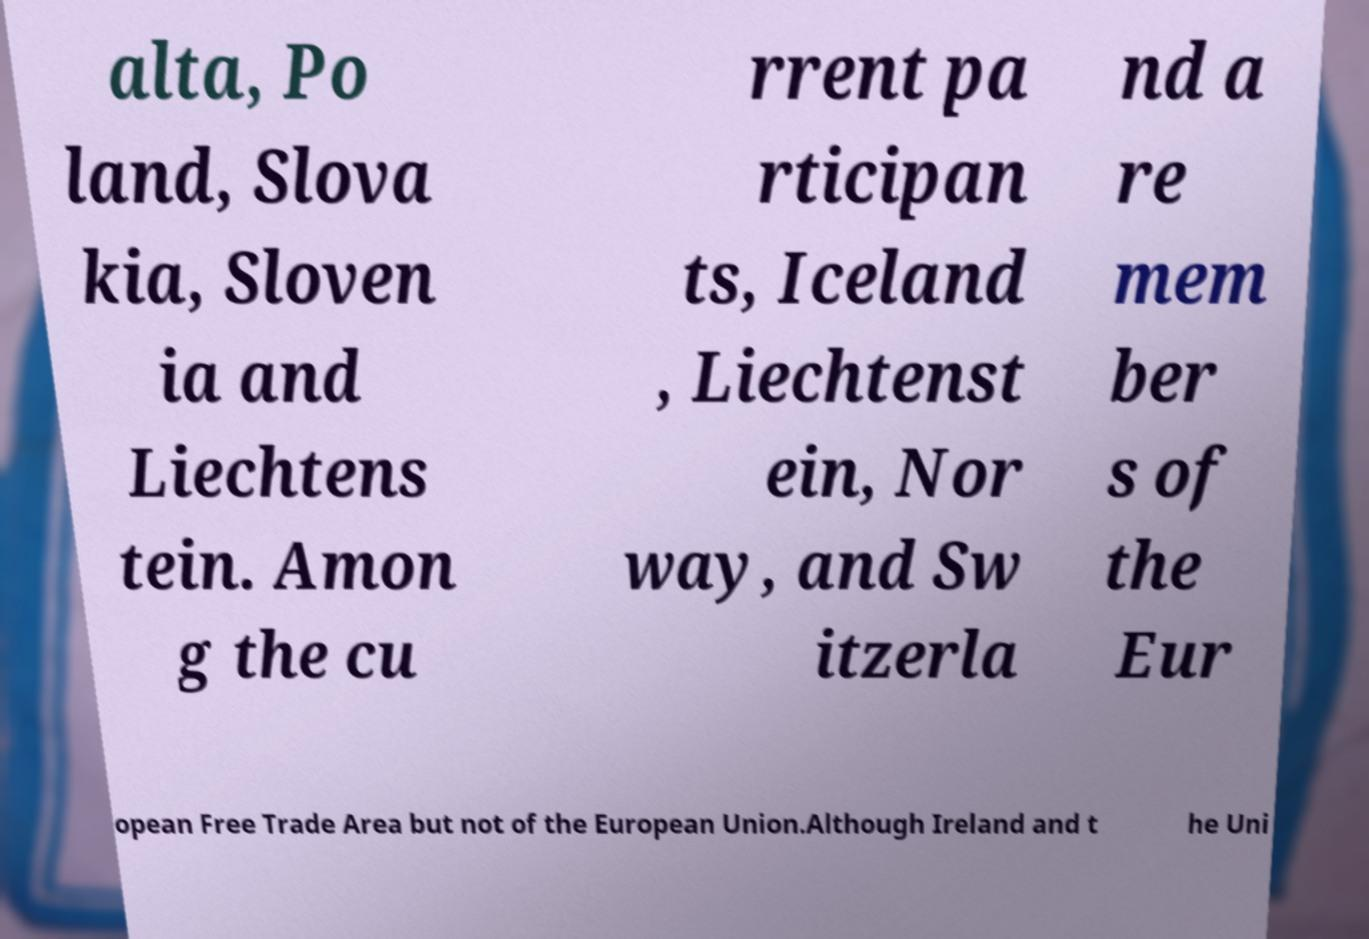Could you extract and type out the text from this image? alta, Po land, Slova kia, Sloven ia and Liechtens tein. Amon g the cu rrent pa rticipan ts, Iceland , Liechtenst ein, Nor way, and Sw itzerla nd a re mem ber s of the Eur opean Free Trade Area but not of the European Union.Although Ireland and t he Uni 